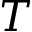<formula> <loc_0><loc_0><loc_500><loc_500>T</formula> 